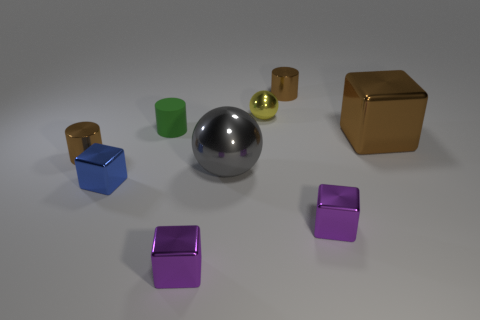How many brown cylinders must be subtracted to get 1 brown cylinders? 1 Subtract all cylinders. How many objects are left? 6 Subtract 1 balls. How many balls are left? 1 Subtract all purple cylinders. Subtract all brown balls. How many cylinders are left? 3 Subtract all brown cylinders. How many brown blocks are left? 1 Subtract all balls. Subtract all small yellow spheres. How many objects are left? 6 Add 5 small spheres. How many small spheres are left? 6 Add 8 tiny yellow objects. How many tiny yellow objects exist? 9 Subtract all brown cylinders. How many cylinders are left? 1 Subtract all small brown cylinders. How many cylinders are left? 1 